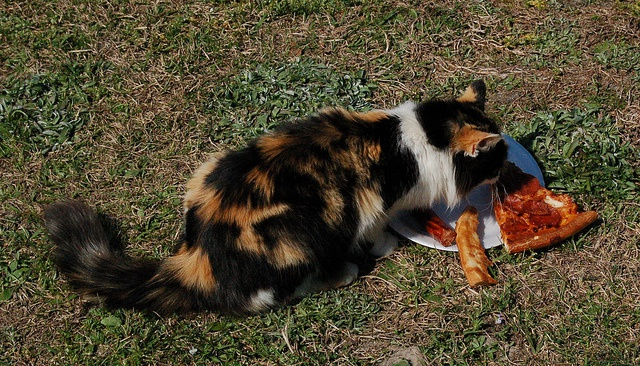Describe the objects in this image and their specific colors. I can see cat in brown, black, maroon, and darkgray tones and pizza in brown, maroon, and black tones in this image. 